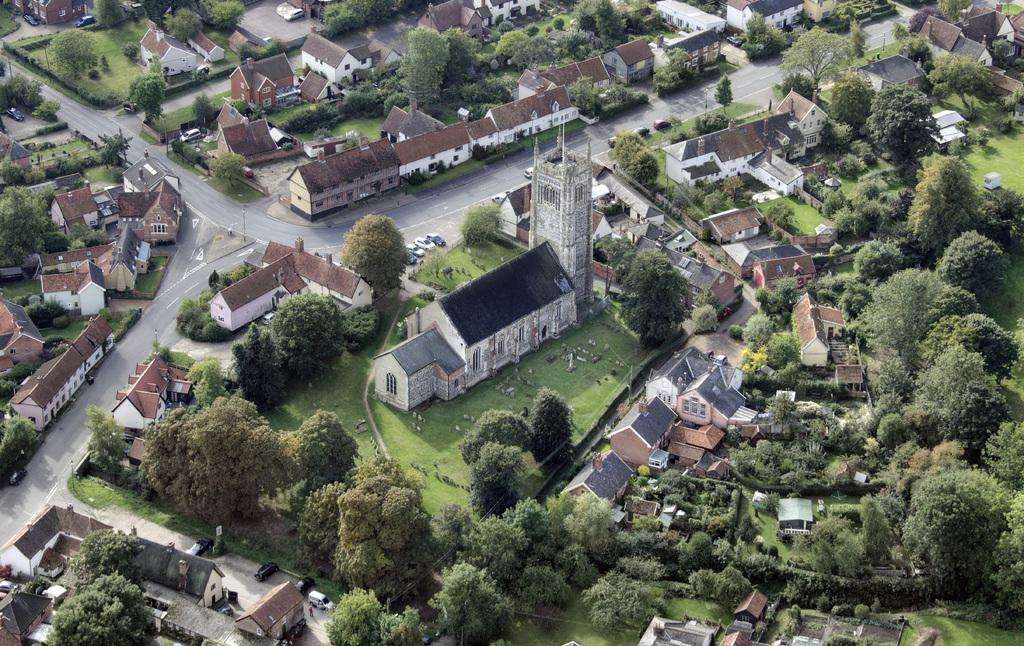What type of structures can be seen in the image? There are buildings in the image. What natural elements are present in the image? There are trees and grass in the image. What type of vehicles can be seen on the road in the image? There are cars on the road in the image. What type of wood can be seen in the image? There is no wood present in the image. What does the grass taste like in the image? The taste of the grass cannot be determined from the image, as it is a visual medium. 